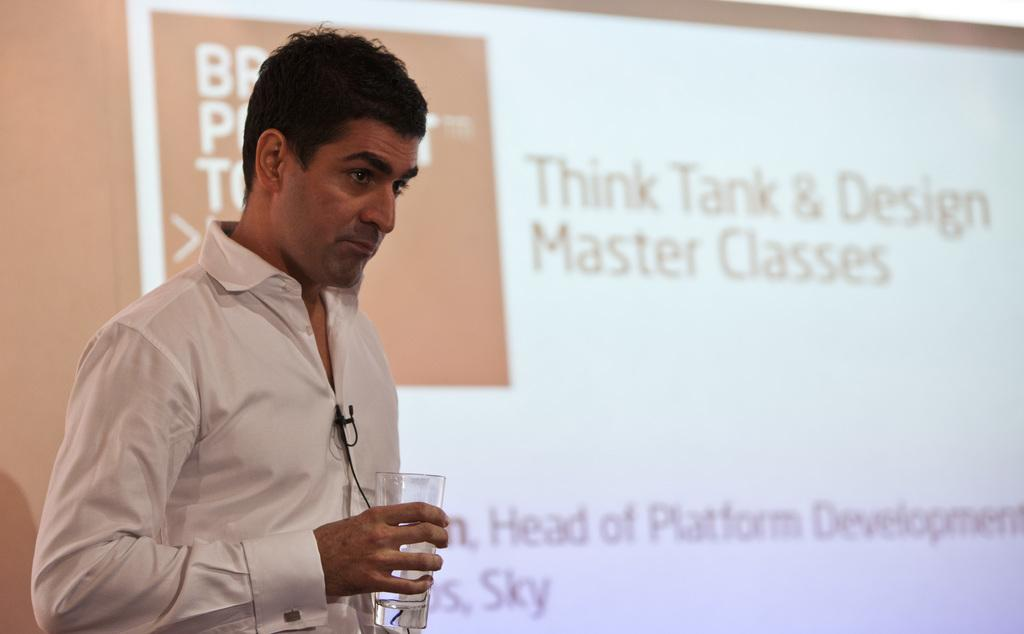What is the main subject of the image? There is a person in the image. What is the person holding in the image? The person is holding a glass. What else can be seen in the image besides the person? There is a screen visible in the image. Can you see any worms crawling on the person's toe in the image? There are no worms or toes visible in the image; it only shows a person holding a glass and a screen. 